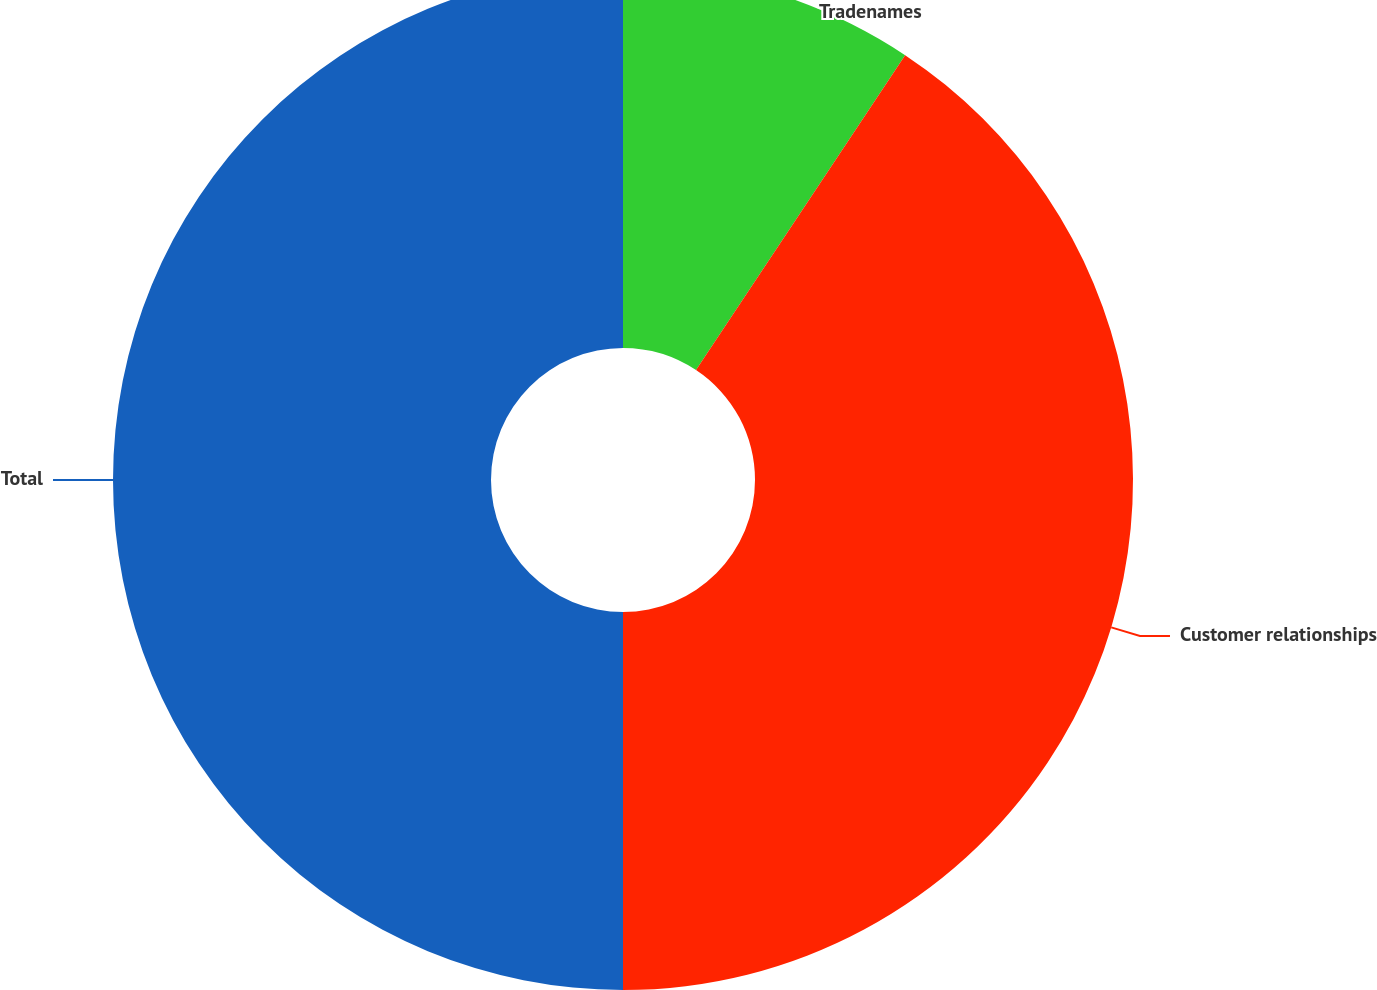Convert chart. <chart><loc_0><loc_0><loc_500><loc_500><pie_chart><fcel>Tradenames<fcel>Customer relationships<fcel>Total<nl><fcel>9.33%<fcel>40.67%<fcel>50.0%<nl></chart> 